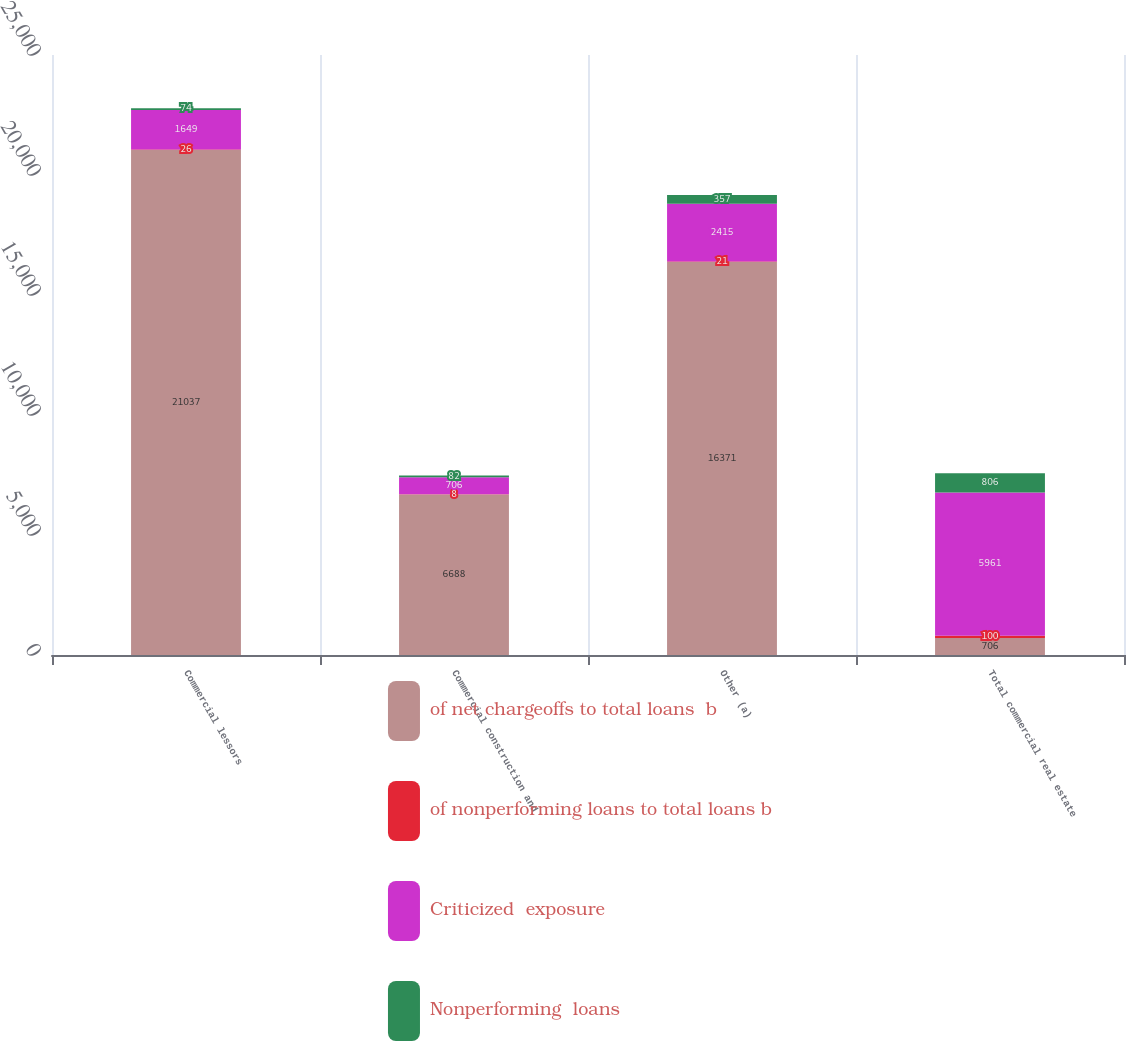<chart> <loc_0><loc_0><loc_500><loc_500><stacked_bar_chart><ecel><fcel>Commercial lessors<fcel>Commercial construction and<fcel>Other (a)<fcel>Total commercial real estate<nl><fcel>of net chargeoffs to total loans  b<fcel>21037<fcel>6688<fcel>16371<fcel>706<nl><fcel>of nonperforming loans to total loans b<fcel>26<fcel>8<fcel>21<fcel>100<nl><fcel>Criticized  exposure<fcel>1649<fcel>706<fcel>2415<fcel>5961<nl><fcel>Nonperforming  loans<fcel>74<fcel>82<fcel>357<fcel>806<nl></chart> 